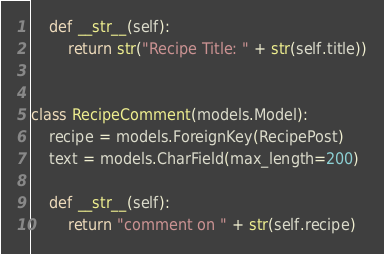<code> <loc_0><loc_0><loc_500><loc_500><_Python_>
    def __str__(self):
        return str("Recipe Title: " + str(self.title))


class RecipeComment(models.Model):
    recipe = models.ForeignKey(RecipePost)
    text = models.CharField(max_length=200)

    def __str__(self):
        return "comment on " + str(self.recipe)
</code> 